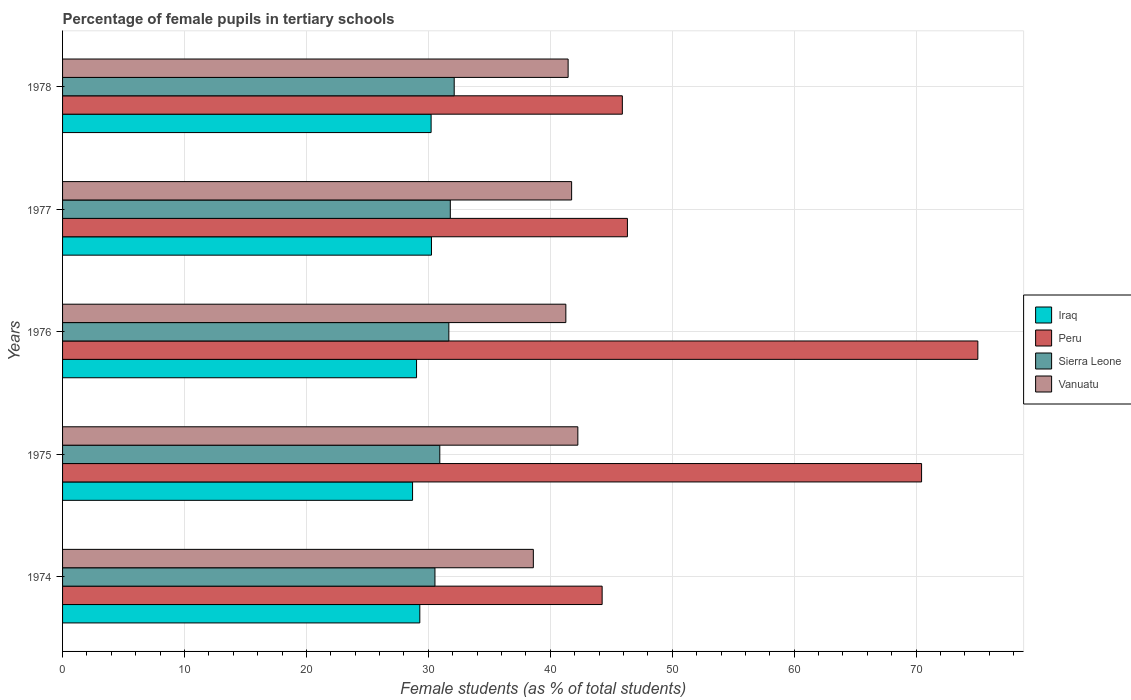How many different coloured bars are there?
Provide a succinct answer. 4. How many bars are there on the 4th tick from the top?
Keep it short and to the point. 4. What is the label of the 3rd group of bars from the top?
Your response must be concise. 1976. What is the percentage of female pupils in tertiary schools in Iraq in 1978?
Offer a very short reply. 30.23. Across all years, what is the maximum percentage of female pupils in tertiary schools in Iraq?
Offer a terse response. 30.25. Across all years, what is the minimum percentage of female pupils in tertiary schools in Vanuatu?
Offer a very short reply. 38.61. In which year was the percentage of female pupils in tertiary schools in Sierra Leone maximum?
Offer a very short reply. 1978. In which year was the percentage of female pupils in tertiary schools in Peru minimum?
Your answer should be very brief. 1974. What is the total percentage of female pupils in tertiary schools in Iraq in the graph?
Offer a very short reply. 147.51. What is the difference between the percentage of female pupils in tertiary schools in Vanuatu in 1975 and that in 1978?
Your answer should be compact. 0.8. What is the difference between the percentage of female pupils in tertiary schools in Iraq in 1975 and the percentage of female pupils in tertiary schools in Peru in 1974?
Your answer should be compact. -15.55. What is the average percentage of female pupils in tertiary schools in Vanuatu per year?
Give a very brief answer. 41.07. In the year 1976, what is the difference between the percentage of female pupils in tertiary schools in Vanuatu and percentage of female pupils in tertiary schools in Iraq?
Keep it short and to the point. 12.24. What is the ratio of the percentage of female pupils in tertiary schools in Iraq in 1974 to that in 1977?
Offer a terse response. 0.97. Is the percentage of female pupils in tertiary schools in Iraq in 1974 less than that in 1976?
Provide a succinct answer. No. Is the difference between the percentage of female pupils in tertiary schools in Vanuatu in 1974 and 1975 greater than the difference between the percentage of female pupils in tertiary schools in Iraq in 1974 and 1975?
Offer a very short reply. No. What is the difference between the highest and the second highest percentage of female pupils in tertiary schools in Iraq?
Offer a very short reply. 0.03. What is the difference between the highest and the lowest percentage of female pupils in tertiary schools in Iraq?
Offer a terse response. 1.55. In how many years, is the percentage of female pupils in tertiary schools in Iraq greater than the average percentage of female pupils in tertiary schools in Iraq taken over all years?
Offer a terse response. 2. Is it the case that in every year, the sum of the percentage of female pupils in tertiary schools in Iraq and percentage of female pupils in tertiary schools in Sierra Leone is greater than the sum of percentage of female pupils in tertiary schools in Vanuatu and percentage of female pupils in tertiary schools in Peru?
Provide a succinct answer. Yes. What does the 2nd bar from the top in 1975 represents?
Provide a short and direct response. Sierra Leone. What does the 1st bar from the bottom in 1978 represents?
Keep it short and to the point. Iraq. How many years are there in the graph?
Keep it short and to the point. 5. What is the difference between two consecutive major ticks on the X-axis?
Your response must be concise. 10. Are the values on the major ticks of X-axis written in scientific E-notation?
Make the answer very short. No. Where does the legend appear in the graph?
Your response must be concise. Center right. What is the title of the graph?
Keep it short and to the point. Percentage of female pupils in tertiary schools. What is the label or title of the X-axis?
Offer a very short reply. Female students (as % of total students). What is the Female students (as % of total students) in Iraq in 1974?
Keep it short and to the point. 29.3. What is the Female students (as % of total students) in Peru in 1974?
Offer a very short reply. 44.25. What is the Female students (as % of total students) of Sierra Leone in 1974?
Your answer should be compact. 30.54. What is the Female students (as % of total students) of Vanuatu in 1974?
Offer a terse response. 38.61. What is the Female students (as % of total students) in Iraq in 1975?
Provide a succinct answer. 28.7. What is the Female students (as % of total students) in Peru in 1975?
Give a very brief answer. 70.45. What is the Female students (as % of total students) of Sierra Leone in 1975?
Give a very brief answer. 30.94. What is the Female students (as % of total students) in Vanuatu in 1975?
Ensure brevity in your answer.  42.26. What is the Female students (as % of total students) of Iraq in 1976?
Ensure brevity in your answer.  29.03. What is the Female students (as % of total students) in Peru in 1976?
Your answer should be compact. 75.06. What is the Female students (as % of total students) in Sierra Leone in 1976?
Offer a terse response. 31.68. What is the Female students (as % of total students) in Vanuatu in 1976?
Offer a very short reply. 41.28. What is the Female students (as % of total students) of Iraq in 1977?
Your answer should be very brief. 30.25. What is the Female students (as % of total students) of Peru in 1977?
Your answer should be very brief. 46.32. What is the Female students (as % of total students) of Sierra Leone in 1977?
Provide a succinct answer. 31.8. What is the Female students (as % of total students) of Vanuatu in 1977?
Keep it short and to the point. 41.75. What is the Female students (as % of total students) in Iraq in 1978?
Your answer should be very brief. 30.23. What is the Female students (as % of total students) of Peru in 1978?
Your answer should be compact. 45.91. What is the Female students (as % of total students) of Sierra Leone in 1978?
Your response must be concise. 32.12. What is the Female students (as % of total students) in Vanuatu in 1978?
Offer a terse response. 41.46. Across all years, what is the maximum Female students (as % of total students) in Iraq?
Your response must be concise. 30.25. Across all years, what is the maximum Female students (as % of total students) in Peru?
Your answer should be very brief. 75.06. Across all years, what is the maximum Female students (as % of total students) of Sierra Leone?
Give a very brief answer. 32.12. Across all years, what is the maximum Female students (as % of total students) in Vanuatu?
Offer a terse response. 42.26. Across all years, what is the minimum Female students (as % of total students) in Iraq?
Your answer should be very brief. 28.7. Across all years, what is the minimum Female students (as % of total students) of Peru?
Offer a very short reply. 44.25. Across all years, what is the minimum Female students (as % of total students) of Sierra Leone?
Your response must be concise. 30.54. Across all years, what is the minimum Female students (as % of total students) in Vanuatu?
Ensure brevity in your answer.  38.61. What is the total Female students (as % of total students) of Iraq in the graph?
Keep it short and to the point. 147.51. What is the total Female students (as % of total students) in Peru in the graph?
Offer a very short reply. 282. What is the total Female students (as % of total students) in Sierra Leone in the graph?
Offer a very short reply. 157.08. What is the total Female students (as % of total students) of Vanuatu in the graph?
Offer a terse response. 205.36. What is the difference between the Female students (as % of total students) in Iraq in 1974 and that in 1975?
Your answer should be compact. 0.59. What is the difference between the Female students (as % of total students) in Peru in 1974 and that in 1975?
Your answer should be compact. -26.2. What is the difference between the Female students (as % of total students) of Sierra Leone in 1974 and that in 1975?
Provide a short and direct response. -0.4. What is the difference between the Female students (as % of total students) of Vanuatu in 1974 and that in 1975?
Give a very brief answer. -3.65. What is the difference between the Female students (as % of total students) in Iraq in 1974 and that in 1976?
Give a very brief answer. 0.27. What is the difference between the Female students (as % of total students) in Peru in 1974 and that in 1976?
Provide a succinct answer. -30.81. What is the difference between the Female students (as % of total students) in Sierra Leone in 1974 and that in 1976?
Your response must be concise. -1.14. What is the difference between the Female students (as % of total students) of Vanuatu in 1974 and that in 1976?
Offer a terse response. -2.67. What is the difference between the Female students (as % of total students) in Iraq in 1974 and that in 1977?
Your answer should be compact. -0.96. What is the difference between the Female students (as % of total students) in Peru in 1974 and that in 1977?
Make the answer very short. -2.07. What is the difference between the Female students (as % of total students) in Sierra Leone in 1974 and that in 1977?
Make the answer very short. -1.26. What is the difference between the Female students (as % of total students) in Vanuatu in 1974 and that in 1977?
Provide a succinct answer. -3.14. What is the difference between the Female students (as % of total students) in Iraq in 1974 and that in 1978?
Your answer should be compact. -0.93. What is the difference between the Female students (as % of total students) in Peru in 1974 and that in 1978?
Ensure brevity in your answer.  -1.66. What is the difference between the Female students (as % of total students) of Sierra Leone in 1974 and that in 1978?
Keep it short and to the point. -1.58. What is the difference between the Female students (as % of total students) of Vanuatu in 1974 and that in 1978?
Your answer should be very brief. -2.85. What is the difference between the Female students (as % of total students) of Iraq in 1975 and that in 1976?
Ensure brevity in your answer.  -0.33. What is the difference between the Female students (as % of total students) in Peru in 1975 and that in 1976?
Offer a terse response. -4.61. What is the difference between the Female students (as % of total students) of Sierra Leone in 1975 and that in 1976?
Offer a terse response. -0.74. What is the difference between the Female students (as % of total students) of Vanuatu in 1975 and that in 1976?
Your response must be concise. 0.98. What is the difference between the Female students (as % of total students) of Iraq in 1975 and that in 1977?
Offer a very short reply. -1.55. What is the difference between the Female students (as % of total students) in Peru in 1975 and that in 1977?
Keep it short and to the point. 24.13. What is the difference between the Female students (as % of total students) of Sierra Leone in 1975 and that in 1977?
Give a very brief answer. -0.86. What is the difference between the Female students (as % of total students) of Vanuatu in 1975 and that in 1977?
Give a very brief answer. 0.51. What is the difference between the Female students (as % of total students) of Iraq in 1975 and that in 1978?
Make the answer very short. -1.52. What is the difference between the Female students (as % of total students) of Peru in 1975 and that in 1978?
Your response must be concise. 24.54. What is the difference between the Female students (as % of total students) in Sierra Leone in 1975 and that in 1978?
Provide a short and direct response. -1.18. What is the difference between the Female students (as % of total students) of Vanuatu in 1975 and that in 1978?
Make the answer very short. 0.8. What is the difference between the Female students (as % of total students) in Iraq in 1976 and that in 1977?
Provide a short and direct response. -1.22. What is the difference between the Female students (as % of total students) in Peru in 1976 and that in 1977?
Ensure brevity in your answer.  28.74. What is the difference between the Female students (as % of total students) in Sierra Leone in 1976 and that in 1977?
Provide a succinct answer. -0.12. What is the difference between the Female students (as % of total students) in Vanuatu in 1976 and that in 1977?
Offer a terse response. -0.47. What is the difference between the Female students (as % of total students) of Iraq in 1976 and that in 1978?
Offer a terse response. -1.19. What is the difference between the Female students (as % of total students) of Peru in 1976 and that in 1978?
Make the answer very short. 29.16. What is the difference between the Female students (as % of total students) in Sierra Leone in 1976 and that in 1978?
Offer a terse response. -0.44. What is the difference between the Female students (as % of total students) of Vanuatu in 1976 and that in 1978?
Give a very brief answer. -0.19. What is the difference between the Female students (as % of total students) of Iraq in 1977 and that in 1978?
Your response must be concise. 0.03. What is the difference between the Female students (as % of total students) of Peru in 1977 and that in 1978?
Ensure brevity in your answer.  0.42. What is the difference between the Female students (as % of total students) in Sierra Leone in 1977 and that in 1978?
Offer a very short reply. -0.32. What is the difference between the Female students (as % of total students) of Vanuatu in 1977 and that in 1978?
Keep it short and to the point. 0.29. What is the difference between the Female students (as % of total students) of Iraq in 1974 and the Female students (as % of total students) of Peru in 1975?
Your response must be concise. -41.15. What is the difference between the Female students (as % of total students) of Iraq in 1974 and the Female students (as % of total students) of Sierra Leone in 1975?
Your answer should be compact. -1.64. What is the difference between the Female students (as % of total students) of Iraq in 1974 and the Female students (as % of total students) of Vanuatu in 1975?
Give a very brief answer. -12.96. What is the difference between the Female students (as % of total students) of Peru in 1974 and the Female students (as % of total students) of Sierra Leone in 1975?
Provide a short and direct response. 13.31. What is the difference between the Female students (as % of total students) of Peru in 1974 and the Female students (as % of total students) of Vanuatu in 1975?
Keep it short and to the point. 1.99. What is the difference between the Female students (as % of total students) in Sierra Leone in 1974 and the Female students (as % of total students) in Vanuatu in 1975?
Offer a very short reply. -11.72. What is the difference between the Female students (as % of total students) of Iraq in 1974 and the Female students (as % of total students) of Peru in 1976?
Offer a terse response. -45.77. What is the difference between the Female students (as % of total students) in Iraq in 1974 and the Female students (as % of total students) in Sierra Leone in 1976?
Give a very brief answer. -2.38. What is the difference between the Female students (as % of total students) in Iraq in 1974 and the Female students (as % of total students) in Vanuatu in 1976?
Keep it short and to the point. -11.98. What is the difference between the Female students (as % of total students) of Peru in 1974 and the Female students (as % of total students) of Sierra Leone in 1976?
Ensure brevity in your answer.  12.57. What is the difference between the Female students (as % of total students) in Peru in 1974 and the Female students (as % of total students) in Vanuatu in 1976?
Ensure brevity in your answer.  2.98. What is the difference between the Female students (as % of total students) of Sierra Leone in 1974 and the Female students (as % of total students) of Vanuatu in 1976?
Make the answer very short. -10.74. What is the difference between the Female students (as % of total students) in Iraq in 1974 and the Female students (as % of total students) in Peru in 1977?
Ensure brevity in your answer.  -17.03. What is the difference between the Female students (as % of total students) in Iraq in 1974 and the Female students (as % of total students) in Sierra Leone in 1977?
Ensure brevity in your answer.  -2.5. What is the difference between the Female students (as % of total students) of Iraq in 1974 and the Female students (as % of total students) of Vanuatu in 1977?
Your response must be concise. -12.45. What is the difference between the Female students (as % of total students) of Peru in 1974 and the Female students (as % of total students) of Sierra Leone in 1977?
Ensure brevity in your answer.  12.45. What is the difference between the Female students (as % of total students) of Peru in 1974 and the Female students (as % of total students) of Vanuatu in 1977?
Keep it short and to the point. 2.5. What is the difference between the Female students (as % of total students) in Sierra Leone in 1974 and the Female students (as % of total students) in Vanuatu in 1977?
Your answer should be compact. -11.21. What is the difference between the Female students (as % of total students) of Iraq in 1974 and the Female students (as % of total students) of Peru in 1978?
Your response must be concise. -16.61. What is the difference between the Female students (as % of total students) in Iraq in 1974 and the Female students (as % of total students) in Sierra Leone in 1978?
Make the answer very short. -2.82. What is the difference between the Female students (as % of total students) of Iraq in 1974 and the Female students (as % of total students) of Vanuatu in 1978?
Offer a terse response. -12.16. What is the difference between the Female students (as % of total students) in Peru in 1974 and the Female students (as % of total students) in Sierra Leone in 1978?
Your response must be concise. 12.13. What is the difference between the Female students (as % of total students) of Peru in 1974 and the Female students (as % of total students) of Vanuatu in 1978?
Provide a short and direct response. 2.79. What is the difference between the Female students (as % of total students) of Sierra Leone in 1974 and the Female students (as % of total students) of Vanuatu in 1978?
Provide a short and direct response. -10.92. What is the difference between the Female students (as % of total students) in Iraq in 1975 and the Female students (as % of total students) in Peru in 1976?
Keep it short and to the point. -46.36. What is the difference between the Female students (as % of total students) of Iraq in 1975 and the Female students (as % of total students) of Sierra Leone in 1976?
Your answer should be compact. -2.98. What is the difference between the Female students (as % of total students) of Iraq in 1975 and the Female students (as % of total students) of Vanuatu in 1976?
Your response must be concise. -12.57. What is the difference between the Female students (as % of total students) of Peru in 1975 and the Female students (as % of total students) of Sierra Leone in 1976?
Provide a short and direct response. 38.77. What is the difference between the Female students (as % of total students) in Peru in 1975 and the Female students (as % of total students) in Vanuatu in 1976?
Offer a very short reply. 29.17. What is the difference between the Female students (as % of total students) of Sierra Leone in 1975 and the Female students (as % of total students) of Vanuatu in 1976?
Make the answer very short. -10.34. What is the difference between the Female students (as % of total students) of Iraq in 1975 and the Female students (as % of total students) of Peru in 1977?
Provide a short and direct response. -17.62. What is the difference between the Female students (as % of total students) of Iraq in 1975 and the Female students (as % of total students) of Sierra Leone in 1977?
Ensure brevity in your answer.  -3.1. What is the difference between the Female students (as % of total students) of Iraq in 1975 and the Female students (as % of total students) of Vanuatu in 1977?
Provide a succinct answer. -13.05. What is the difference between the Female students (as % of total students) of Peru in 1975 and the Female students (as % of total students) of Sierra Leone in 1977?
Your answer should be compact. 38.65. What is the difference between the Female students (as % of total students) in Peru in 1975 and the Female students (as % of total students) in Vanuatu in 1977?
Offer a terse response. 28.7. What is the difference between the Female students (as % of total students) in Sierra Leone in 1975 and the Female students (as % of total students) in Vanuatu in 1977?
Keep it short and to the point. -10.81. What is the difference between the Female students (as % of total students) of Iraq in 1975 and the Female students (as % of total students) of Peru in 1978?
Give a very brief answer. -17.2. What is the difference between the Female students (as % of total students) in Iraq in 1975 and the Female students (as % of total students) in Sierra Leone in 1978?
Give a very brief answer. -3.42. What is the difference between the Female students (as % of total students) in Iraq in 1975 and the Female students (as % of total students) in Vanuatu in 1978?
Your response must be concise. -12.76. What is the difference between the Female students (as % of total students) in Peru in 1975 and the Female students (as % of total students) in Sierra Leone in 1978?
Your answer should be very brief. 38.33. What is the difference between the Female students (as % of total students) of Peru in 1975 and the Female students (as % of total students) of Vanuatu in 1978?
Provide a succinct answer. 28.99. What is the difference between the Female students (as % of total students) of Sierra Leone in 1975 and the Female students (as % of total students) of Vanuatu in 1978?
Make the answer very short. -10.52. What is the difference between the Female students (as % of total students) in Iraq in 1976 and the Female students (as % of total students) in Peru in 1977?
Your answer should be very brief. -17.29. What is the difference between the Female students (as % of total students) in Iraq in 1976 and the Female students (as % of total students) in Sierra Leone in 1977?
Your response must be concise. -2.77. What is the difference between the Female students (as % of total students) of Iraq in 1976 and the Female students (as % of total students) of Vanuatu in 1977?
Provide a short and direct response. -12.72. What is the difference between the Female students (as % of total students) in Peru in 1976 and the Female students (as % of total students) in Sierra Leone in 1977?
Give a very brief answer. 43.26. What is the difference between the Female students (as % of total students) in Peru in 1976 and the Female students (as % of total students) in Vanuatu in 1977?
Provide a succinct answer. 33.31. What is the difference between the Female students (as % of total students) of Sierra Leone in 1976 and the Female students (as % of total students) of Vanuatu in 1977?
Provide a succinct answer. -10.07. What is the difference between the Female students (as % of total students) of Iraq in 1976 and the Female students (as % of total students) of Peru in 1978?
Offer a terse response. -16.88. What is the difference between the Female students (as % of total students) in Iraq in 1976 and the Female students (as % of total students) in Sierra Leone in 1978?
Provide a short and direct response. -3.09. What is the difference between the Female students (as % of total students) of Iraq in 1976 and the Female students (as % of total students) of Vanuatu in 1978?
Your answer should be compact. -12.43. What is the difference between the Female students (as % of total students) in Peru in 1976 and the Female students (as % of total students) in Sierra Leone in 1978?
Your answer should be very brief. 42.94. What is the difference between the Female students (as % of total students) of Peru in 1976 and the Female students (as % of total students) of Vanuatu in 1978?
Provide a short and direct response. 33.6. What is the difference between the Female students (as % of total students) of Sierra Leone in 1976 and the Female students (as % of total students) of Vanuatu in 1978?
Your answer should be very brief. -9.78. What is the difference between the Female students (as % of total students) of Iraq in 1977 and the Female students (as % of total students) of Peru in 1978?
Your answer should be very brief. -15.65. What is the difference between the Female students (as % of total students) in Iraq in 1977 and the Female students (as % of total students) in Sierra Leone in 1978?
Ensure brevity in your answer.  -1.86. What is the difference between the Female students (as % of total students) of Iraq in 1977 and the Female students (as % of total students) of Vanuatu in 1978?
Give a very brief answer. -11.21. What is the difference between the Female students (as % of total students) in Peru in 1977 and the Female students (as % of total students) in Sierra Leone in 1978?
Ensure brevity in your answer.  14.21. What is the difference between the Female students (as % of total students) in Peru in 1977 and the Female students (as % of total students) in Vanuatu in 1978?
Provide a succinct answer. 4.86. What is the difference between the Female students (as % of total students) in Sierra Leone in 1977 and the Female students (as % of total students) in Vanuatu in 1978?
Make the answer very short. -9.66. What is the average Female students (as % of total students) in Iraq per year?
Ensure brevity in your answer.  29.5. What is the average Female students (as % of total students) in Peru per year?
Provide a short and direct response. 56.4. What is the average Female students (as % of total students) in Sierra Leone per year?
Your answer should be compact. 31.41. What is the average Female students (as % of total students) in Vanuatu per year?
Offer a very short reply. 41.07. In the year 1974, what is the difference between the Female students (as % of total students) in Iraq and Female students (as % of total students) in Peru?
Offer a very short reply. -14.95. In the year 1974, what is the difference between the Female students (as % of total students) in Iraq and Female students (as % of total students) in Sierra Leone?
Ensure brevity in your answer.  -1.24. In the year 1974, what is the difference between the Female students (as % of total students) of Iraq and Female students (as % of total students) of Vanuatu?
Provide a succinct answer. -9.31. In the year 1974, what is the difference between the Female students (as % of total students) in Peru and Female students (as % of total students) in Sierra Leone?
Provide a short and direct response. 13.71. In the year 1974, what is the difference between the Female students (as % of total students) of Peru and Female students (as % of total students) of Vanuatu?
Ensure brevity in your answer.  5.64. In the year 1974, what is the difference between the Female students (as % of total students) in Sierra Leone and Female students (as % of total students) in Vanuatu?
Offer a very short reply. -8.07. In the year 1975, what is the difference between the Female students (as % of total students) of Iraq and Female students (as % of total students) of Peru?
Your answer should be very brief. -41.75. In the year 1975, what is the difference between the Female students (as % of total students) of Iraq and Female students (as % of total students) of Sierra Leone?
Provide a short and direct response. -2.23. In the year 1975, what is the difference between the Female students (as % of total students) of Iraq and Female students (as % of total students) of Vanuatu?
Give a very brief answer. -13.56. In the year 1975, what is the difference between the Female students (as % of total students) of Peru and Female students (as % of total students) of Sierra Leone?
Make the answer very short. 39.51. In the year 1975, what is the difference between the Female students (as % of total students) in Peru and Female students (as % of total students) in Vanuatu?
Give a very brief answer. 28.19. In the year 1975, what is the difference between the Female students (as % of total students) in Sierra Leone and Female students (as % of total students) in Vanuatu?
Your response must be concise. -11.32. In the year 1976, what is the difference between the Female students (as % of total students) of Iraq and Female students (as % of total students) of Peru?
Ensure brevity in your answer.  -46.03. In the year 1976, what is the difference between the Female students (as % of total students) of Iraq and Female students (as % of total students) of Sierra Leone?
Make the answer very short. -2.65. In the year 1976, what is the difference between the Female students (as % of total students) in Iraq and Female students (as % of total students) in Vanuatu?
Make the answer very short. -12.24. In the year 1976, what is the difference between the Female students (as % of total students) in Peru and Female students (as % of total students) in Sierra Leone?
Offer a terse response. 43.38. In the year 1976, what is the difference between the Female students (as % of total students) of Peru and Female students (as % of total students) of Vanuatu?
Provide a succinct answer. 33.79. In the year 1976, what is the difference between the Female students (as % of total students) in Sierra Leone and Female students (as % of total students) in Vanuatu?
Keep it short and to the point. -9.6. In the year 1977, what is the difference between the Female students (as % of total students) in Iraq and Female students (as % of total students) in Peru?
Your response must be concise. -16.07. In the year 1977, what is the difference between the Female students (as % of total students) in Iraq and Female students (as % of total students) in Sierra Leone?
Provide a short and direct response. -1.54. In the year 1977, what is the difference between the Female students (as % of total students) of Iraq and Female students (as % of total students) of Vanuatu?
Make the answer very short. -11.49. In the year 1977, what is the difference between the Female students (as % of total students) in Peru and Female students (as % of total students) in Sierra Leone?
Offer a very short reply. 14.53. In the year 1977, what is the difference between the Female students (as % of total students) in Peru and Female students (as % of total students) in Vanuatu?
Keep it short and to the point. 4.58. In the year 1977, what is the difference between the Female students (as % of total students) in Sierra Leone and Female students (as % of total students) in Vanuatu?
Your response must be concise. -9.95. In the year 1978, what is the difference between the Female students (as % of total students) in Iraq and Female students (as % of total students) in Peru?
Ensure brevity in your answer.  -15.68. In the year 1978, what is the difference between the Female students (as % of total students) of Iraq and Female students (as % of total students) of Sierra Leone?
Your response must be concise. -1.89. In the year 1978, what is the difference between the Female students (as % of total students) of Iraq and Female students (as % of total students) of Vanuatu?
Offer a very short reply. -11.24. In the year 1978, what is the difference between the Female students (as % of total students) of Peru and Female students (as % of total students) of Sierra Leone?
Make the answer very short. 13.79. In the year 1978, what is the difference between the Female students (as % of total students) in Peru and Female students (as % of total students) in Vanuatu?
Offer a very short reply. 4.45. In the year 1978, what is the difference between the Female students (as % of total students) of Sierra Leone and Female students (as % of total students) of Vanuatu?
Your response must be concise. -9.34. What is the ratio of the Female students (as % of total students) of Iraq in 1974 to that in 1975?
Provide a short and direct response. 1.02. What is the ratio of the Female students (as % of total students) of Peru in 1974 to that in 1975?
Offer a terse response. 0.63. What is the ratio of the Female students (as % of total students) in Sierra Leone in 1974 to that in 1975?
Keep it short and to the point. 0.99. What is the ratio of the Female students (as % of total students) of Vanuatu in 1974 to that in 1975?
Your answer should be very brief. 0.91. What is the ratio of the Female students (as % of total students) of Iraq in 1974 to that in 1976?
Your answer should be very brief. 1.01. What is the ratio of the Female students (as % of total students) of Peru in 1974 to that in 1976?
Provide a short and direct response. 0.59. What is the ratio of the Female students (as % of total students) of Vanuatu in 1974 to that in 1976?
Make the answer very short. 0.94. What is the ratio of the Female students (as % of total students) in Iraq in 1974 to that in 1977?
Your response must be concise. 0.97. What is the ratio of the Female students (as % of total students) in Peru in 1974 to that in 1977?
Keep it short and to the point. 0.96. What is the ratio of the Female students (as % of total students) of Sierra Leone in 1974 to that in 1977?
Your response must be concise. 0.96. What is the ratio of the Female students (as % of total students) of Vanuatu in 1974 to that in 1977?
Offer a terse response. 0.92. What is the ratio of the Female students (as % of total students) in Iraq in 1974 to that in 1978?
Offer a very short reply. 0.97. What is the ratio of the Female students (as % of total students) of Peru in 1974 to that in 1978?
Ensure brevity in your answer.  0.96. What is the ratio of the Female students (as % of total students) in Sierra Leone in 1974 to that in 1978?
Make the answer very short. 0.95. What is the ratio of the Female students (as % of total students) in Vanuatu in 1974 to that in 1978?
Offer a terse response. 0.93. What is the ratio of the Female students (as % of total students) of Iraq in 1975 to that in 1976?
Ensure brevity in your answer.  0.99. What is the ratio of the Female students (as % of total students) in Peru in 1975 to that in 1976?
Keep it short and to the point. 0.94. What is the ratio of the Female students (as % of total students) in Sierra Leone in 1975 to that in 1976?
Keep it short and to the point. 0.98. What is the ratio of the Female students (as % of total students) in Vanuatu in 1975 to that in 1976?
Offer a very short reply. 1.02. What is the ratio of the Female students (as % of total students) in Iraq in 1975 to that in 1977?
Offer a very short reply. 0.95. What is the ratio of the Female students (as % of total students) in Peru in 1975 to that in 1977?
Ensure brevity in your answer.  1.52. What is the ratio of the Female students (as % of total students) of Sierra Leone in 1975 to that in 1977?
Provide a succinct answer. 0.97. What is the ratio of the Female students (as % of total students) of Vanuatu in 1975 to that in 1977?
Provide a short and direct response. 1.01. What is the ratio of the Female students (as % of total students) in Iraq in 1975 to that in 1978?
Your answer should be very brief. 0.95. What is the ratio of the Female students (as % of total students) of Peru in 1975 to that in 1978?
Ensure brevity in your answer.  1.53. What is the ratio of the Female students (as % of total students) in Sierra Leone in 1975 to that in 1978?
Offer a very short reply. 0.96. What is the ratio of the Female students (as % of total students) in Vanuatu in 1975 to that in 1978?
Ensure brevity in your answer.  1.02. What is the ratio of the Female students (as % of total students) in Iraq in 1976 to that in 1977?
Your answer should be very brief. 0.96. What is the ratio of the Female students (as % of total students) in Peru in 1976 to that in 1977?
Provide a short and direct response. 1.62. What is the ratio of the Female students (as % of total students) of Vanuatu in 1976 to that in 1977?
Your response must be concise. 0.99. What is the ratio of the Female students (as % of total students) of Iraq in 1976 to that in 1978?
Provide a succinct answer. 0.96. What is the ratio of the Female students (as % of total students) in Peru in 1976 to that in 1978?
Offer a terse response. 1.64. What is the ratio of the Female students (as % of total students) in Sierra Leone in 1976 to that in 1978?
Your answer should be compact. 0.99. What is the ratio of the Female students (as % of total students) of Vanuatu in 1976 to that in 1978?
Your answer should be compact. 1. What is the ratio of the Female students (as % of total students) of Peru in 1977 to that in 1978?
Keep it short and to the point. 1.01. What is the ratio of the Female students (as % of total students) in Sierra Leone in 1977 to that in 1978?
Ensure brevity in your answer.  0.99. What is the difference between the highest and the second highest Female students (as % of total students) of Iraq?
Your response must be concise. 0.03. What is the difference between the highest and the second highest Female students (as % of total students) of Peru?
Provide a short and direct response. 4.61. What is the difference between the highest and the second highest Female students (as % of total students) of Sierra Leone?
Provide a succinct answer. 0.32. What is the difference between the highest and the second highest Female students (as % of total students) in Vanuatu?
Offer a very short reply. 0.51. What is the difference between the highest and the lowest Female students (as % of total students) of Iraq?
Your answer should be very brief. 1.55. What is the difference between the highest and the lowest Female students (as % of total students) in Peru?
Provide a succinct answer. 30.81. What is the difference between the highest and the lowest Female students (as % of total students) of Sierra Leone?
Provide a succinct answer. 1.58. What is the difference between the highest and the lowest Female students (as % of total students) in Vanuatu?
Provide a succinct answer. 3.65. 